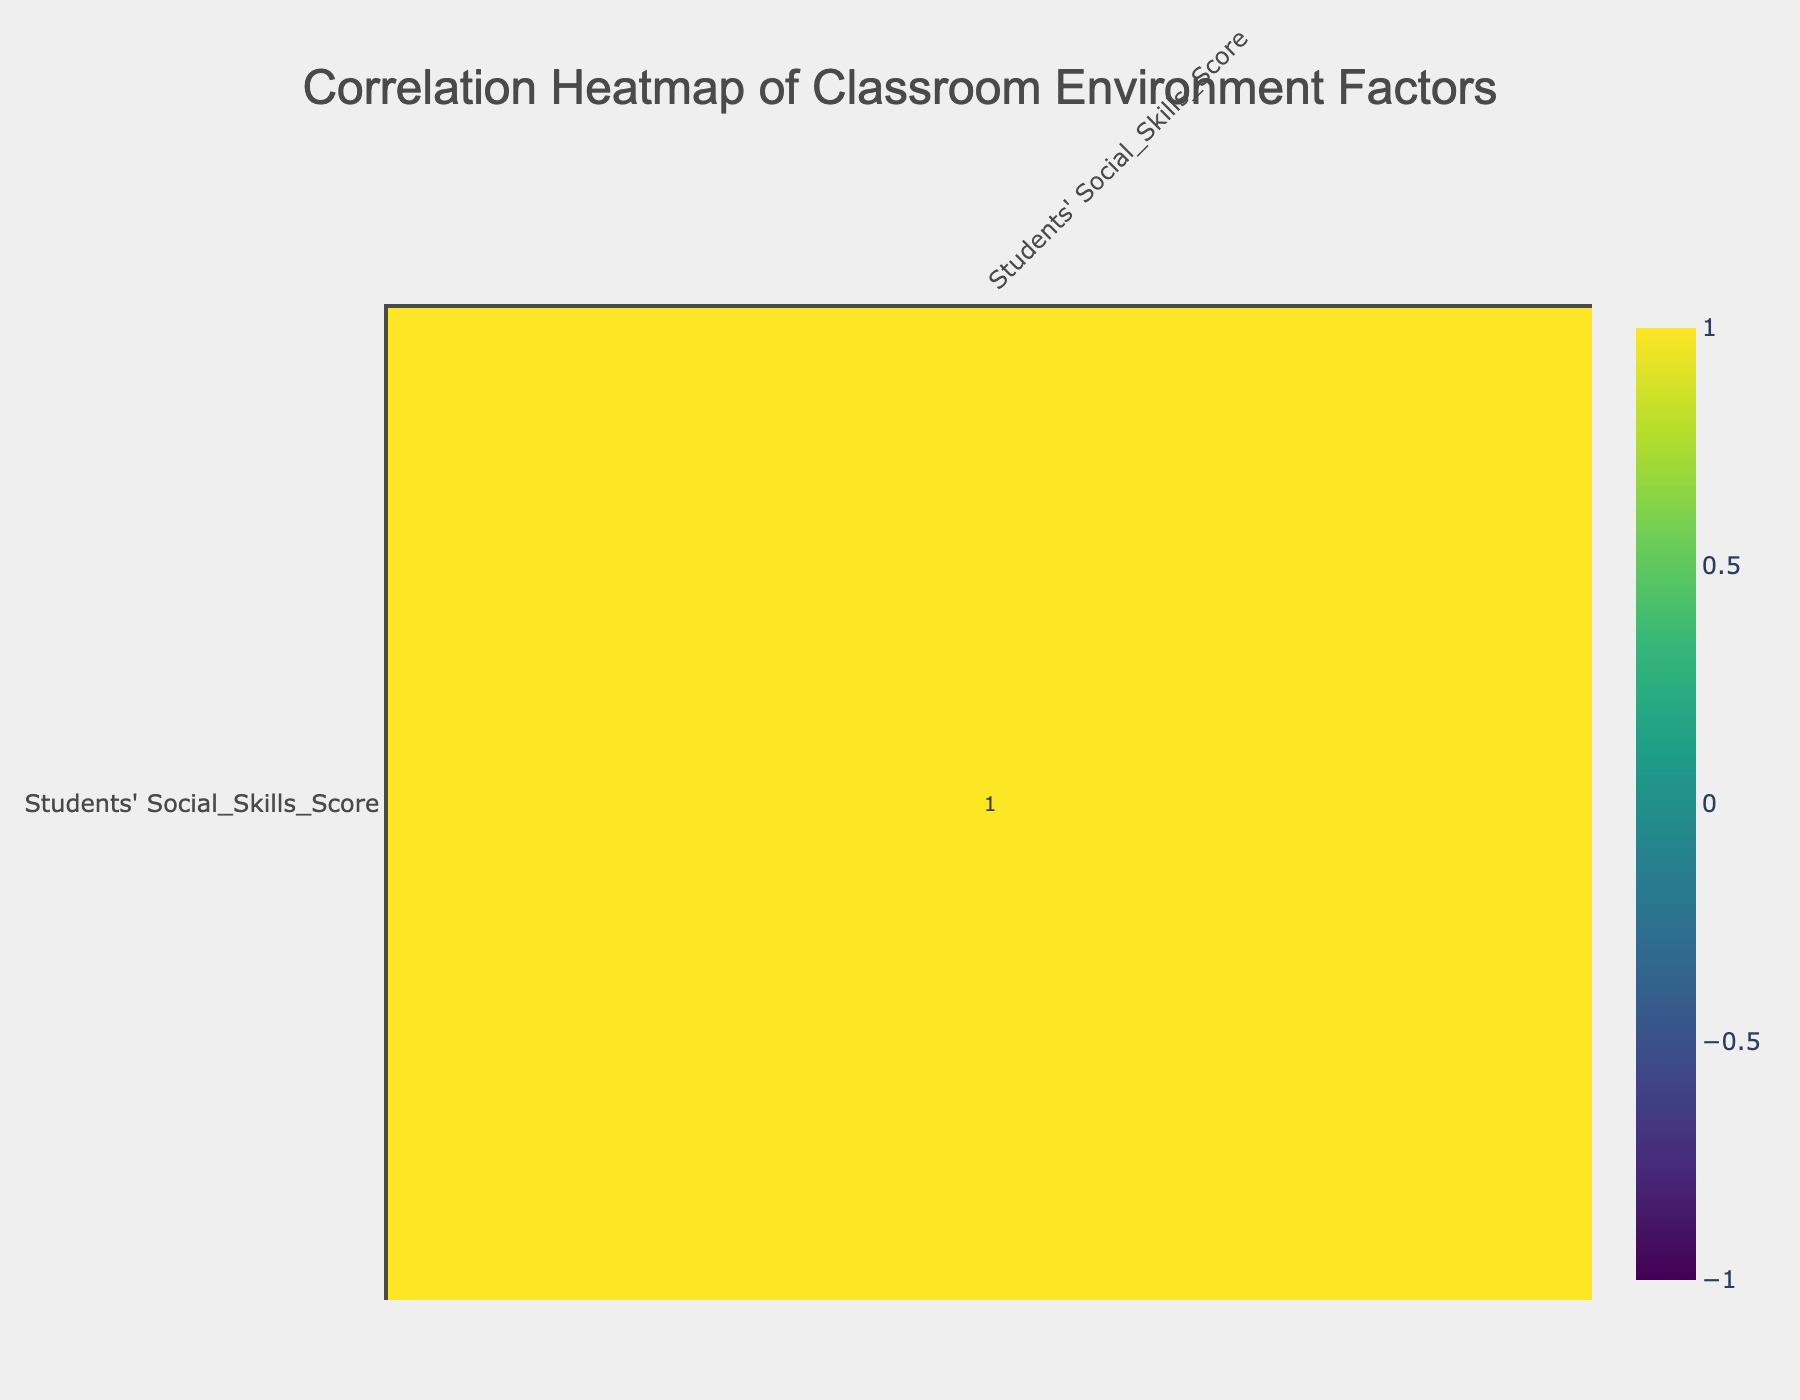What is the social skills score for the classroom with open space design? The table shows that the "Open_Space" classroom has a corresponding social skills score of 85. This value can be found directly aligned with the classroom design in the relevant row.
Answer: 85 What is the correlation between Teacher Engagement Level and Students' Social Skills Score? The correlation value between "Teacher_Engagement_Level" and "Students' Social_Skills_Score" can be found in the correlation matrix, which indicates a positive correlation of 0.73, suggesting that a higher level of teacher engagement is associated with higher social skills scores.
Answer: 0.73 Is the social skills score for students in classrooms with Isolation Desks lower than those with Traditional desks? The isolation desks scored 45 in social skills, while traditional desks scored 70. Since 45 is lower than 70, the statement is true.
Answer: Yes What is the average social skills score for classrooms with high-quality supplies? The social skills scores for classrooms with high-quality supplies are 85 (Open_Space), 90 (Flexible_Seating), 88 (Interactive_Whiteboards), and 80 (Collaborative_Tables). Adding these gives 343, and dividing by 4 (number of scores) gives an average of 85.75.
Answer: 85.75 Which classroom design has the lowest score for students' social skills? By examining the table, it is clear that "Isolation_Desks" has the lowest social skills score of 45, as seen in that specific row of the table.
Answer: 45 What is the relationship between Peer Interaction Frequency and the overall Students' Social Skills Score? The correlation between "Peer_Interaction_Frequency" and "Students' Social_Skills_Score" in the correlation matrix shows a strong positive correlation of 0.78, indicating that more frequent peer interactions are linked to higher social skills scores.
Answer: 0.78 Do classrooms with minimal supplies have a better social skills score than those with collaborative tables? The score for minimal supplies is 50, while the score for collaborative tables is 80. Since 50 is not better than 80, the statement is false.
Answer: No What is the difference in social skills scores between classrooms with high peer interaction and those with low peer interaction? Classrooms with high peer interaction (scores of 85, 90, 80, 88) have an average score of 85.75, while low peer interaction classrooms (scores of 70, 45, 50, 40) have an average of 51.25. The difference is 85.75 - 51.25 = 34.5.
Answer: 34.5 